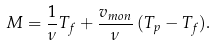Convert formula to latex. <formula><loc_0><loc_0><loc_500><loc_500>M = \frac { 1 } { \nu } T _ { f } + \frac { v _ { m o n } } { \nu } \, ( T _ { p } - T _ { f } ) .</formula> 